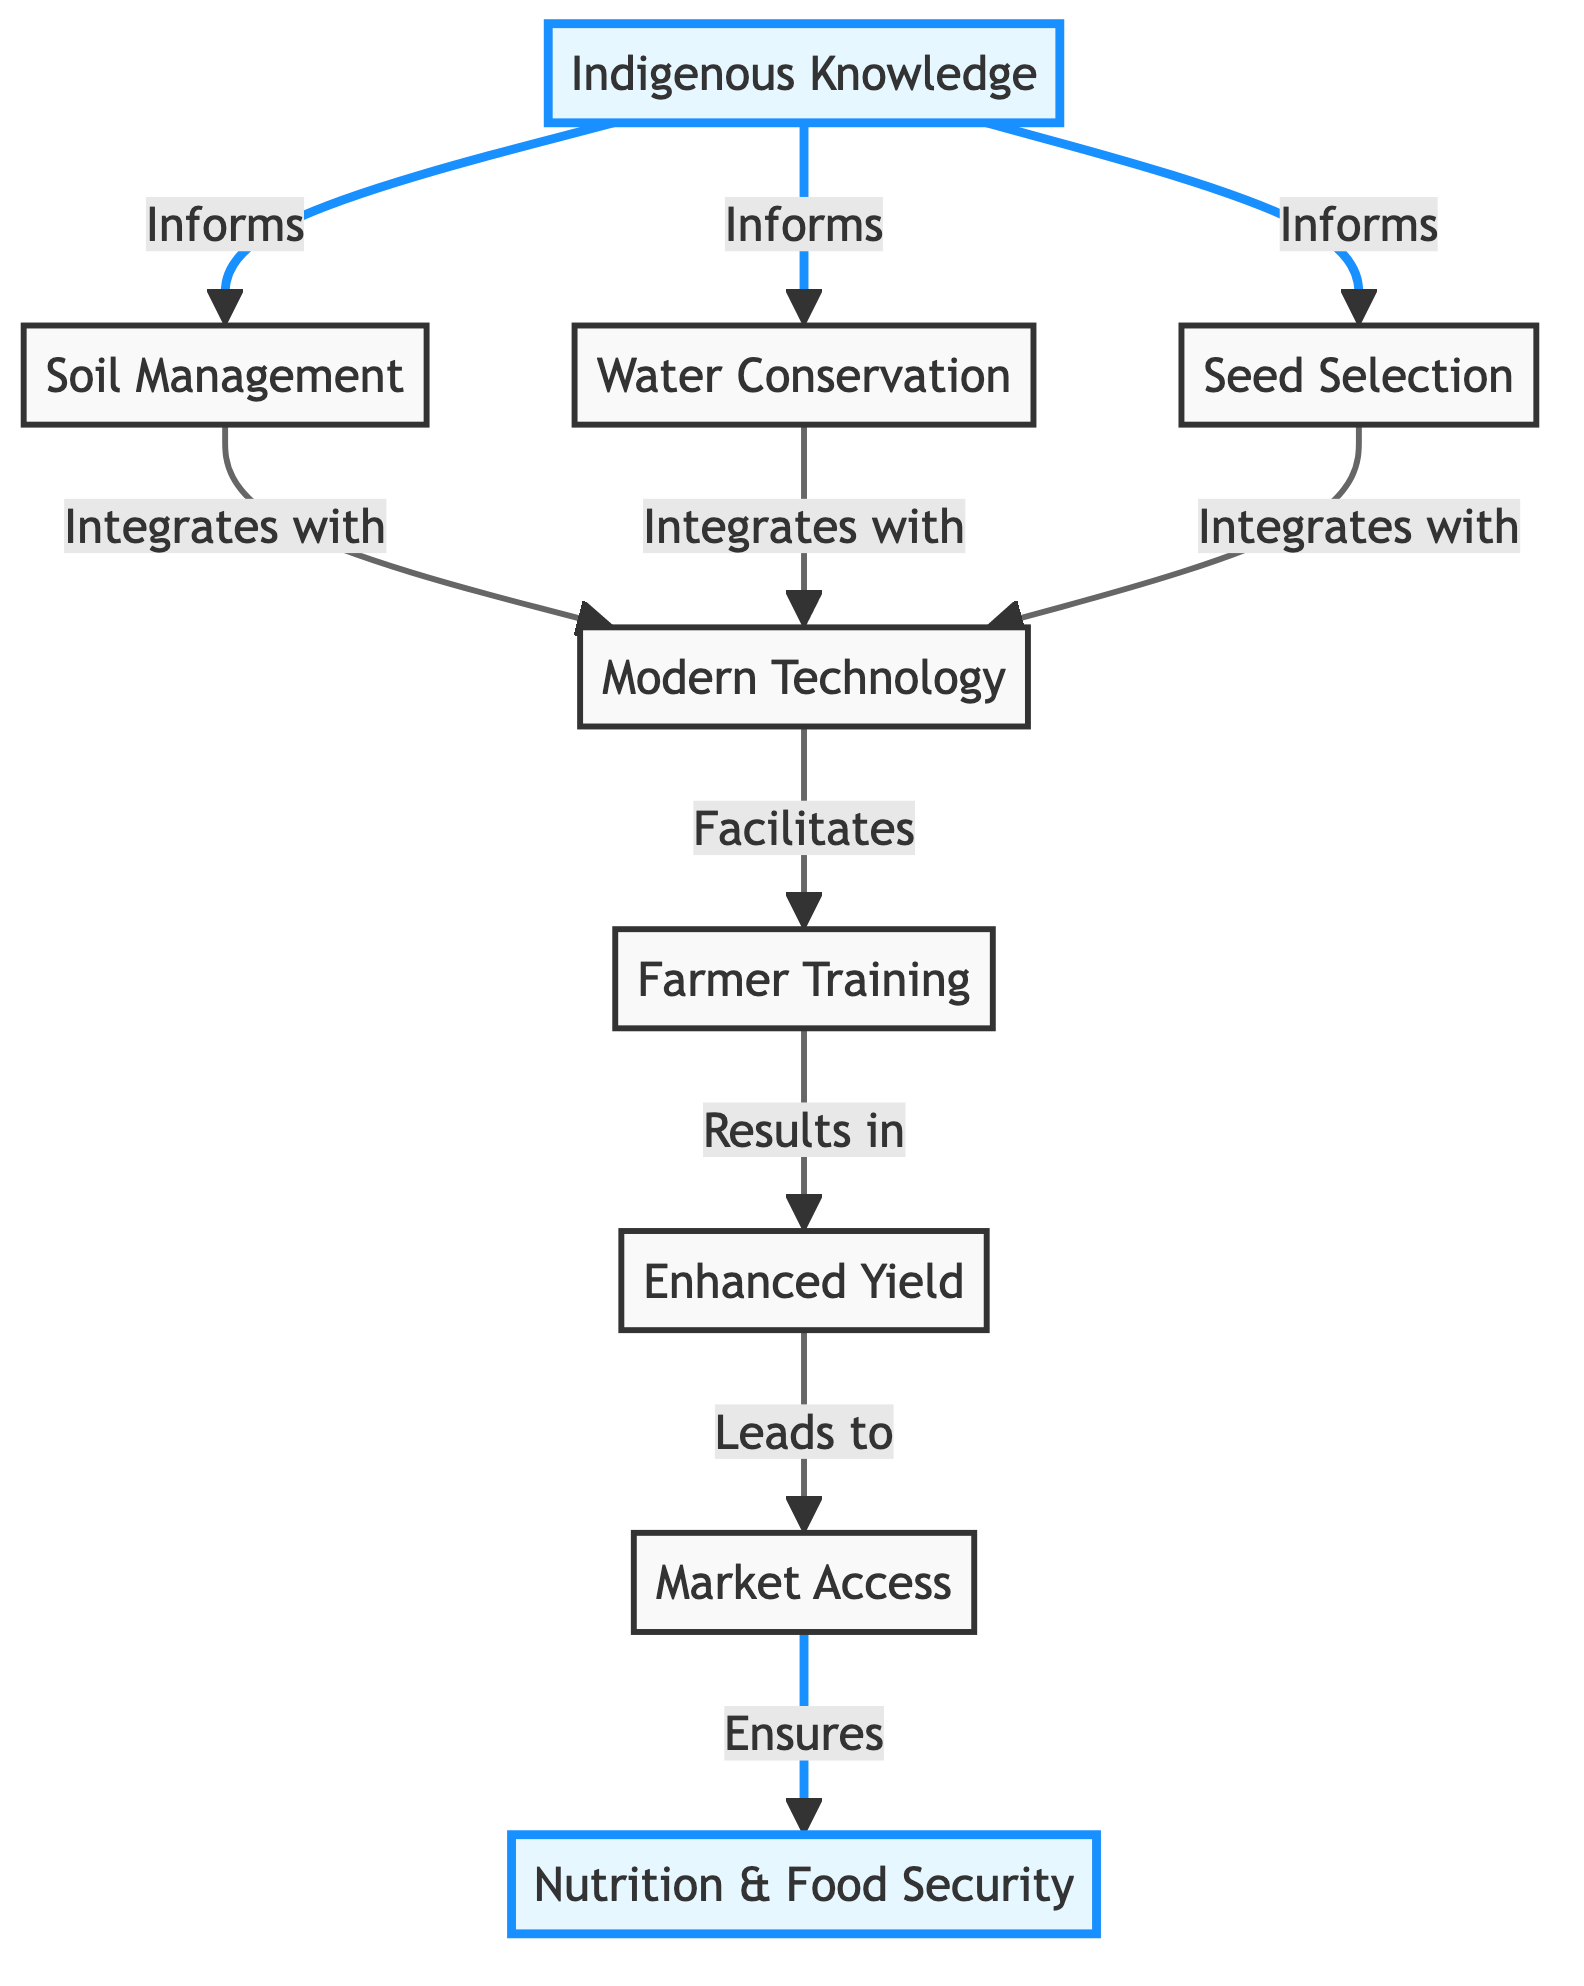What is the first node in the diagram? The first node listed in the diagram represents "Indigenous Knowledge," signifying its foundational role in the integration process.
Answer: Indigenous Knowledge How many total nodes are present in the diagram? Counting all the nodes listed, there are 9 nodes shown in the diagram, signifying various components of the integration process.
Answer: 9 What does "Soil Management" integrate with? According to the diagram, "Soil Management" integrates with "Modern Technology," indicating its collaboration with advanced techniques in agriculture.
Answer: Modern Technology Which node leads to "Market Access"? The node that leads to "Market Access" is "Enhanced Yield," showing that increased agricultural productivity connects to better market opportunities.
Answer: Enhanced Yield What informs "Water Conservation"? The diagram indicates that "Indigenous Knowledge" informs "Water Conservation," highlighting the influence of traditional practices on modern water-saving techniques.
Answer: Indigenous Knowledge What is the relationship between "Seed Selection" and "Modern Technology"? The relationship is that "Seed Selection" integrates with "Modern Technology," indicating that traditional practices are combined with technological advances in this area.
Answer: Integrates with What is the outcome of "Farmer Training"? The outcome of "Farmer Training" is "Enhanced Yield," demonstrating the direct impact of education and training on agricultural productivity.
Answer: Enhanced Yield Which node ensures "Nutrition & Food Security"? The node that ensures "Nutrition & Food Security" is "Market Access," indicating that access to markets is crucial for achieving food security and nutrition.
Answer: Market Access Describe the flow from "Indigenous Knowledge" to "Nutrition & Food Security". The flow begins with "Indigenous Knowledge," which informs "Soil Management," "Water Conservation," and "Seed Selection." These practices integrate with "Modern Technology," which facilitates "Farmer Training." The result of training is "Enhanced Yield," which leads to "Market Access," ultimately ensuring "Nutrition & Food Security."
Answer: Indigenous Knowledge → Soil Management, Water Conservation, Seed Selection → Modern Technology → Farmer Training → Enhanced Yield → Market Access → Nutrition & Food Security 